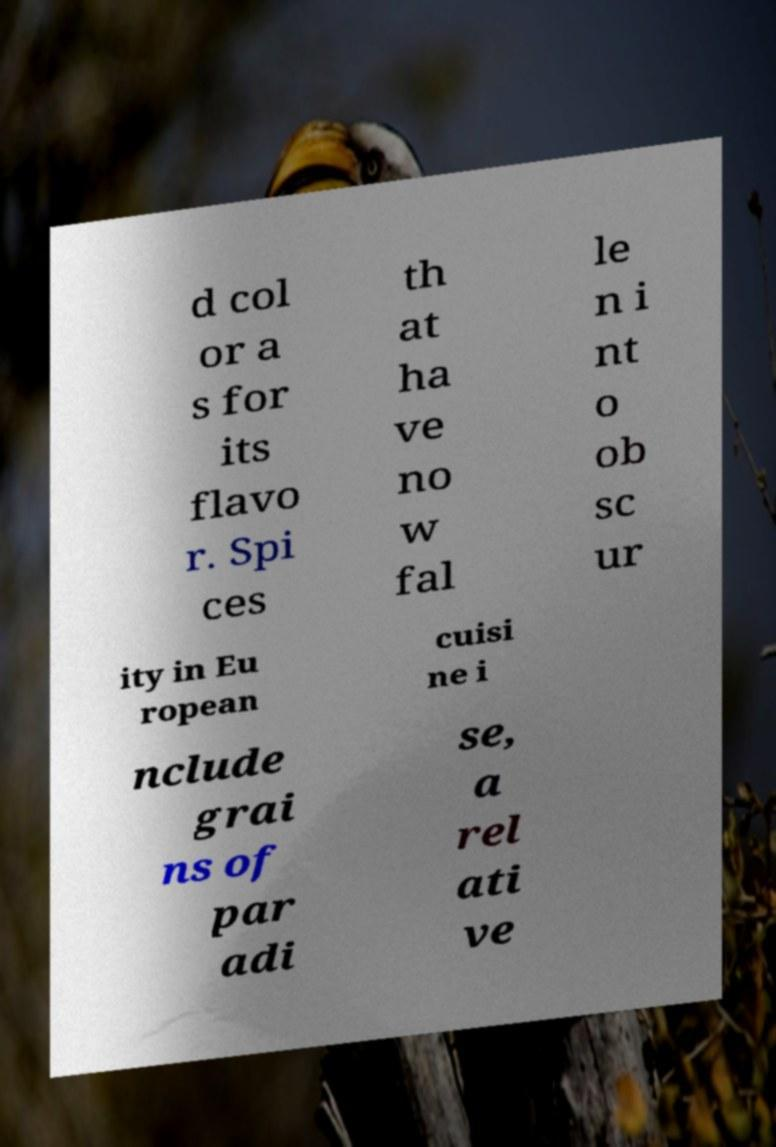What messages or text are displayed in this image? I need them in a readable, typed format. d col or a s for its flavo r. Spi ces th at ha ve no w fal le n i nt o ob sc ur ity in Eu ropean cuisi ne i nclude grai ns of par adi se, a rel ati ve 